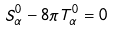Convert formula to latex. <formula><loc_0><loc_0><loc_500><loc_500>S ^ { 0 } _ { \alpha } - 8 \pi T ^ { 0 } _ { \alpha } = 0</formula> 